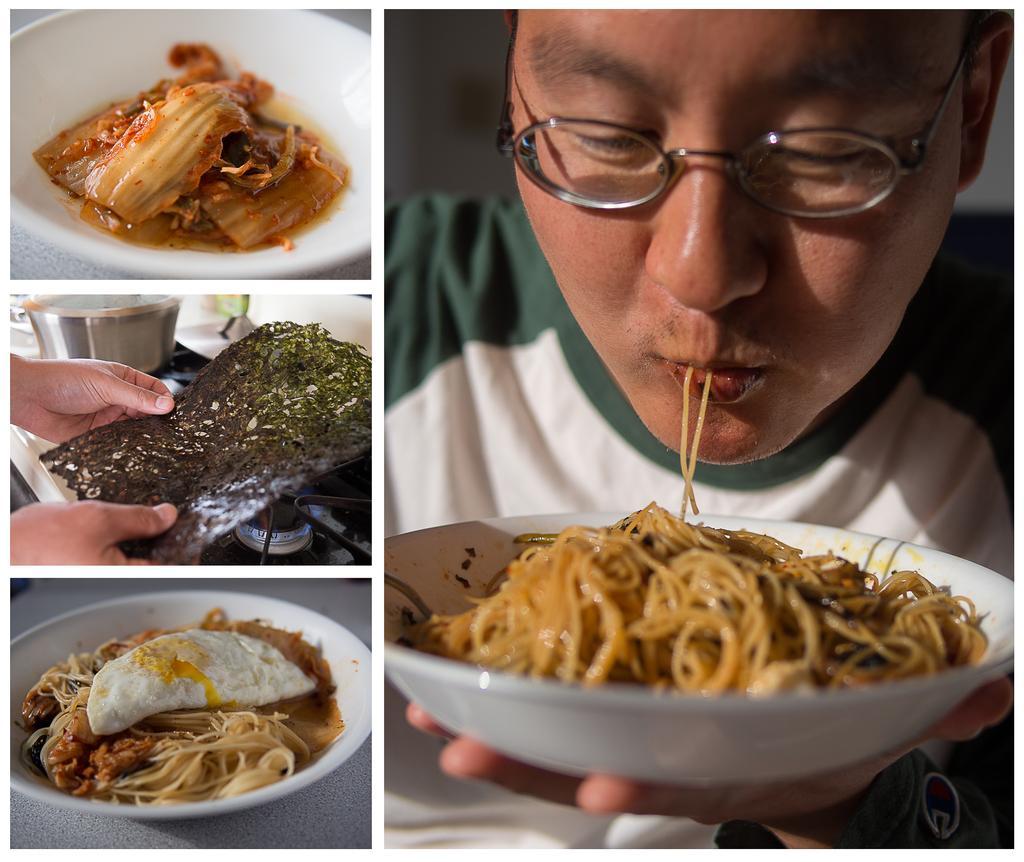In one or two sentences, can you explain what this image depicts? In this image I can see collage photos of plates and in these places I can see different types of food. Here I can see a man is holding a plate and I can see he is wearing specs. I can also see hands of a person is holding an object over here. 